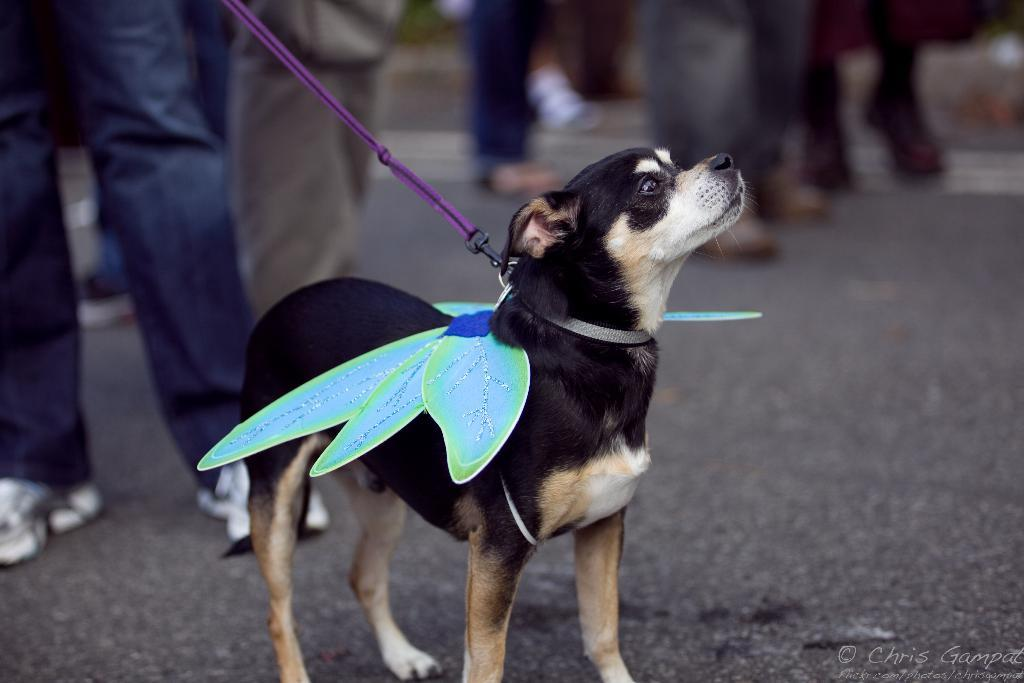What animal can be seen in the image? There is a dog in the image. Where is the dog located? The dog is standing on the road. What is unique about the dog's appearance? The dog is wearing wings. Who is controlling the dog in the image? There is a person holding the rope of the dog's neck. Can you describe the background of the image? The background of the image is slightly blurry. What type of development is taking place in the image? There is no development project or construction site visible in the image; it features a dog standing on the road. What kind of beast is depicted in the image? The image does not feature any mythical or fantastical beasts; it shows a dog wearing wings. 